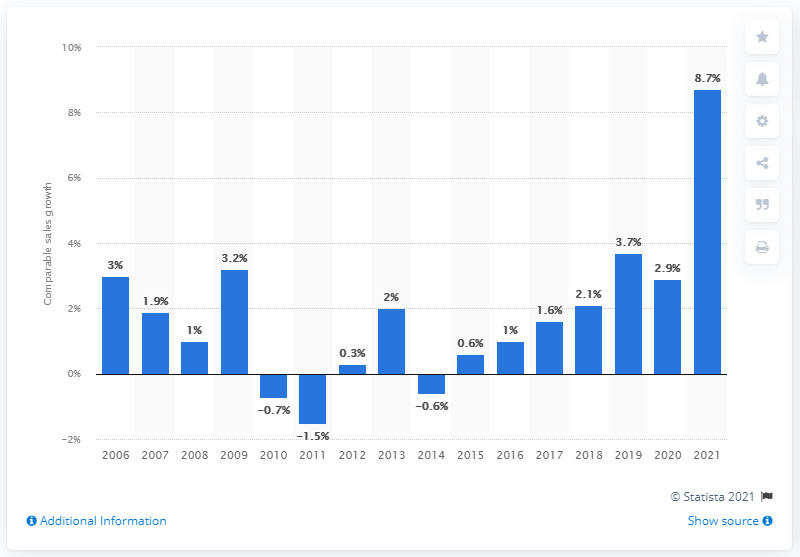Give some essential details in this illustration. In fiscal year 2021, Walmart's net sales increased by 8.7%. 